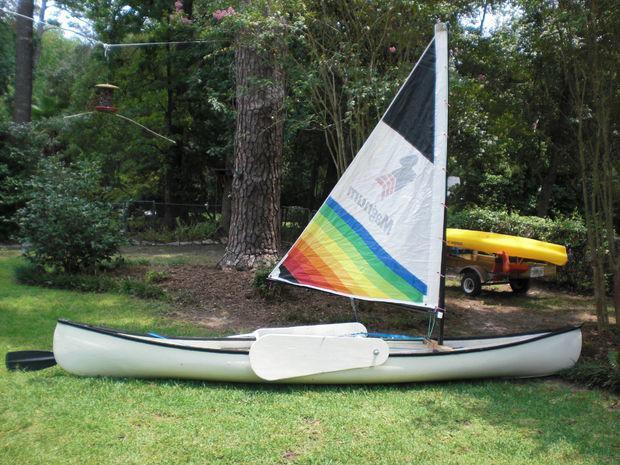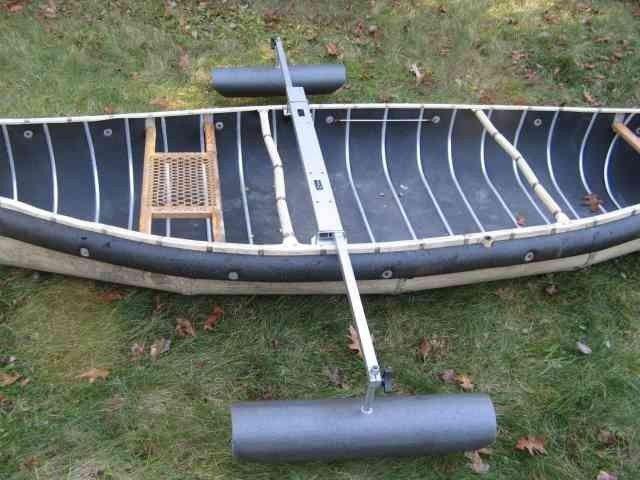The first image is the image on the left, the second image is the image on the right. Considering the images on both sides, is "At least one person is in a boat floating on water." valid? Answer yes or no. No. The first image is the image on the left, the second image is the image on the right. Considering the images on both sides, is "An image shows at least one person in a yellow canoe on the water." valid? Answer yes or no. No. 